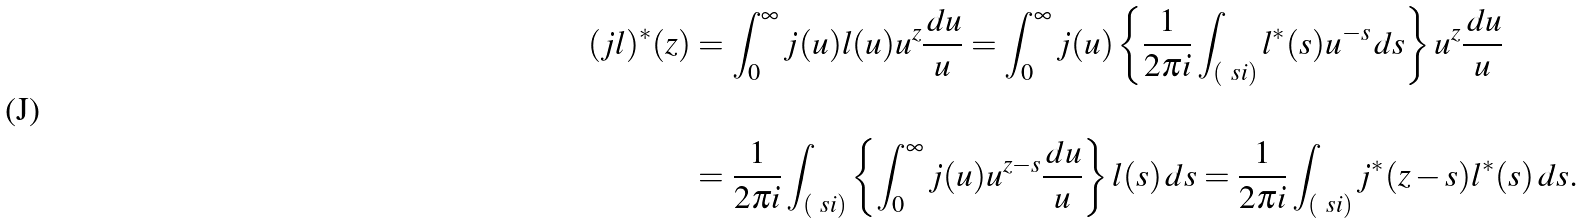<formula> <loc_0><loc_0><loc_500><loc_500>( j l ) ^ { * } ( z ) & = \int _ { 0 } ^ { \infty } j ( u ) l ( u ) u ^ { z } \frac { \, d u } { u } = \int _ { 0 } ^ { \infty } j ( u ) \left \{ \frac { 1 } { 2 \pi i } \int _ { ( \ s i ) } l ^ { * } ( s ) u ^ { - s } \, d s \right \} u ^ { z } \frac { \, d u } { u } \\ \\ & = \frac { 1 } { 2 \pi i } \int _ { ( \ s i ) } \left \{ \int _ { 0 } ^ { \infty } j ( u ) u ^ { z - s } \frac { \, d u } { u } \right \} l ( s ) \, d s = \frac { 1 } { 2 \pi i } \int _ { ( \ s i ) } j ^ { * } ( z - s ) l ^ { * } ( s ) \, d s .</formula> 